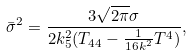Convert formula to latex. <formula><loc_0><loc_0><loc_500><loc_500>{ \bar { \sigma } } ^ { 2 } = \frac { 3 \sqrt { 2 \pi } \sigma } { 2 k _ { 5 } ^ { 2 } ( T _ { 4 4 } - \frac { 1 } { 1 6 k ^ { 2 } } T ^ { 4 } ) } ,</formula> 